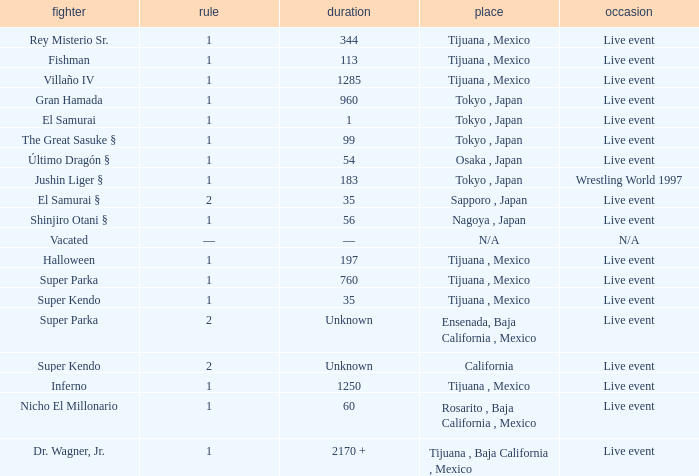Where did the wrestler, super parka, with the title with a reign of 2? Ensenada, Baja California , Mexico. Would you mind parsing the complete table? {'header': ['fighter', 'rule', 'duration', 'place', 'occasion'], 'rows': [['Rey Misterio Sr.', '1', '344', 'Tijuana , Mexico', 'Live event'], ['Fishman', '1', '113', 'Tijuana , Mexico', 'Live event'], ['Villaño IV', '1', '1285', 'Tijuana , Mexico', 'Live event'], ['Gran Hamada', '1', '960', 'Tokyo , Japan', 'Live event'], ['El Samurai', '1', '1', 'Tokyo , Japan', 'Live event'], ['The Great Sasuke §', '1', '99', 'Tokyo , Japan', 'Live event'], ['Último Dragón §', '1', '54', 'Osaka , Japan', 'Live event'], ['Jushin Liger §', '1', '183', 'Tokyo , Japan', 'Wrestling World 1997'], ['El Samurai §', '2', '35', 'Sapporo , Japan', 'Live event'], ['Shinjiro Otani §', '1', '56', 'Nagoya , Japan', 'Live event'], ['Vacated', '—', '—', 'N/A', 'N/A'], ['Halloween', '1', '197', 'Tijuana , Mexico', 'Live event'], ['Super Parka', '1', '760', 'Tijuana , Mexico', 'Live event'], ['Super Kendo', '1', '35', 'Tijuana , Mexico', 'Live event'], ['Super Parka', '2', 'Unknown', 'Ensenada, Baja California , Mexico', 'Live event'], ['Super Kendo', '2', 'Unknown', 'California', 'Live event'], ['Inferno', '1', '1250', 'Tijuana , Mexico', 'Live event'], ['Nicho El Millonario', '1', '60', 'Rosarito , Baja California , Mexico', 'Live event'], ['Dr. Wagner, Jr.', '1', '2170 +', 'Tijuana , Baja California , Mexico', 'Live event']]} 